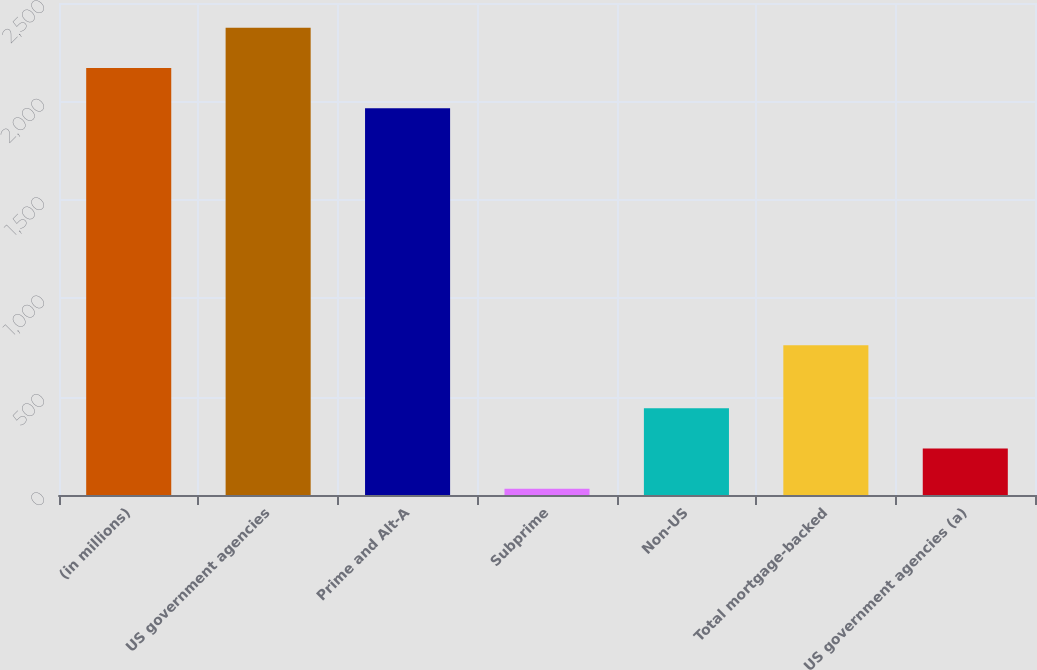Convert chart. <chart><loc_0><loc_0><loc_500><loc_500><bar_chart><fcel>(in millions)<fcel>US government agencies<fcel>Prime and Alt-A<fcel>Subprime<fcel>Non-US<fcel>Total mortgage-backed<fcel>US government agencies (a)<nl><fcel>2169.4<fcel>2373.8<fcel>1965<fcel>32<fcel>440.8<fcel>761<fcel>236.4<nl></chart> 